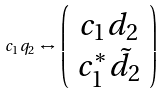Convert formula to latex. <formula><loc_0><loc_0><loc_500><loc_500>c _ { 1 } q _ { 2 } \, \leftrightarrow \, \left ( \begin{array} { c } c _ { 1 } d _ { 2 } \\ c _ { 1 } ^ { * } \tilde { d } _ { 2 } \end{array} \right )</formula> 